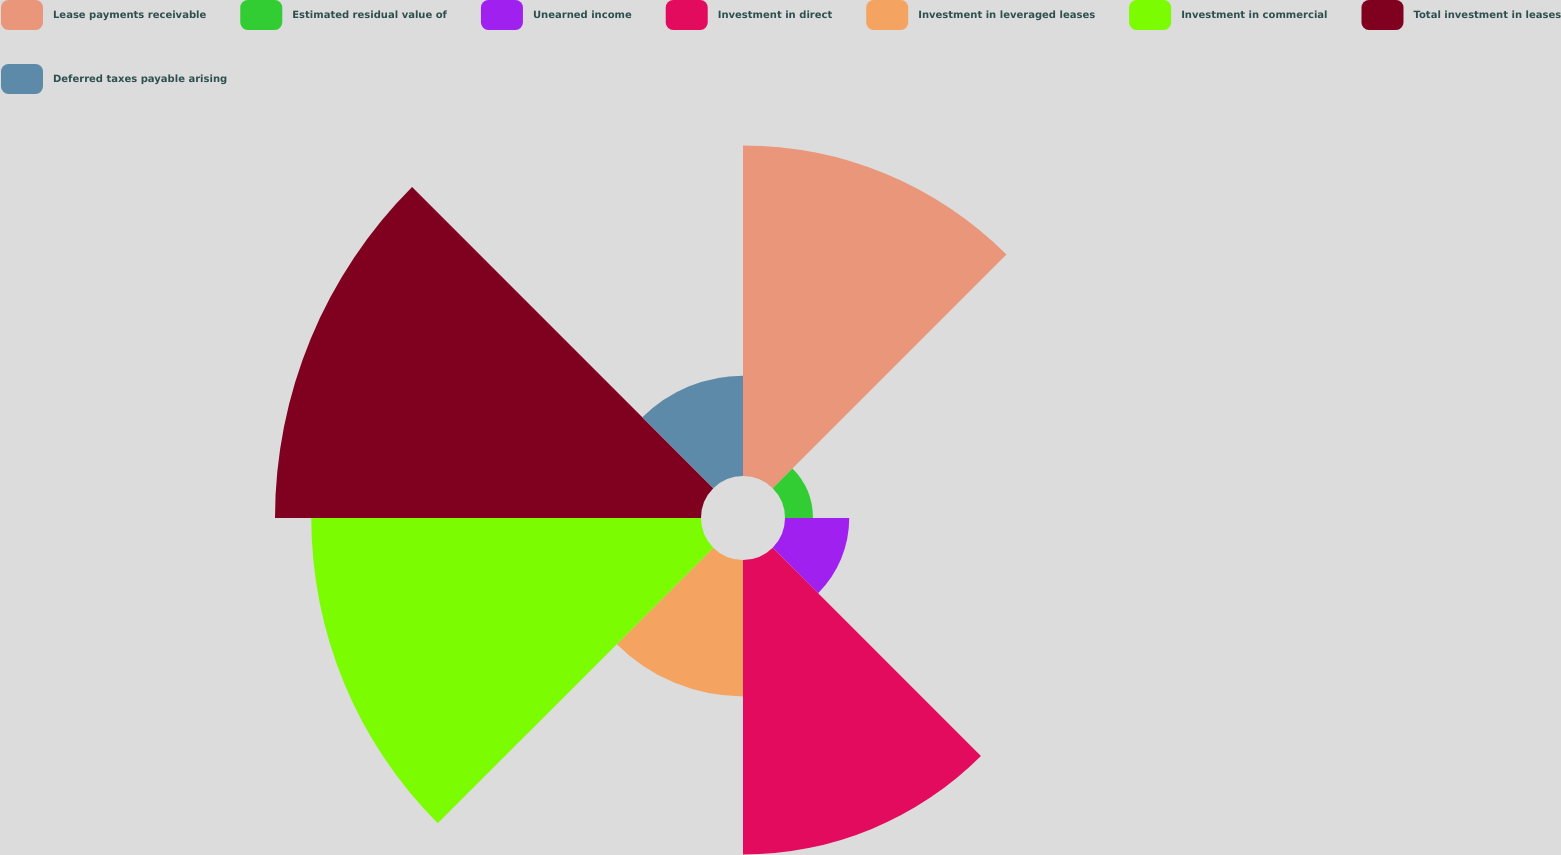Convert chart to OTSL. <chart><loc_0><loc_0><loc_500><loc_500><pie_chart><fcel>Lease payments receivable<fcel>Estimated residual value of<fcel>Unearned income<fcel>Investment in direct<fcel>Investment in leveraged leases<fcel>Investment in commercial<fcel>Total investment in leases<fcel>Deferred taxes payable arising<nl><fcel>18.68%<fcel>1.58%<fcel>3.63%<fcel>16.64%<fcel>7.71%<fcel>22.02%<fcel>24.07%<fcel>5.67%<nl></chart> 